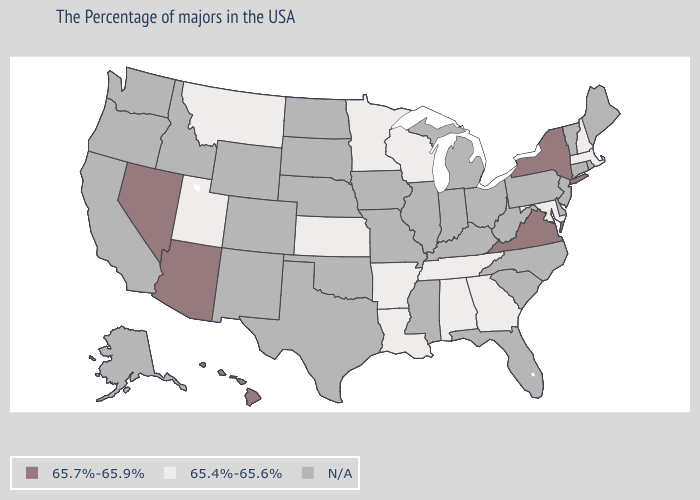Which states have the lowest value in the Northeast?
Quick response, please. Massachusetts, New Hampshire. What is the highest value in the Northeast ?
Keep it brief. 65.7%-65.9%. Which states have the lowest value in the West?
Be succinct. Utah, Montana. What is the value of Arizona?
Concise answer only. 65.7%-65.9%. Which states hav the highest value in the West?
Write a very short answer. Arizona, Nevada, Hawaii. What is the highest value in the South ?
Quick response, please. 65.7%-65.9%. Among the states that border Kentucky , which have the highest value?
Write a very short answer. Virginia. Does Virginia have the highest value in the USA?
Keep it brief. Yes. Name the states that have a value in the range 65.7%-65.9%?
Concise answer only. New York, Virginia, Arizona, Nevada, Hawaii. What is the value of Massachusetts?
Quick response, please. 65.4%-65.6%. Name the states that have a value in the range N/A?
Quick response, please. Maine, Rhode Island, Vermont, Connecticut, New Jersey, Delaware, Pennsylvania, North Carolina, South Carolina, West Virginia, Ohio, Florida, Michigan, Kentucky, Indiana, Illinois, Mississippi, Missouri, Iowa, Nebraska, Oklahoma, Texas, South Dakota, North Dakota, Wyoming, Colorado, New Mexico, Idaho, California, Washington, Oregon, Alaska. Does the map have missing data?
Quick response, please. Yes. Name the states that have a value in the range 65.7%-65.9%?
Answer briefly. New York, Virginia, Arizona, Nevada, Hawaii. Name the states that have a value in the range N/A?
Answer briefly. Maine, Rhode Island, Vermont, Connecticut, New Jersey, Delaware, Pennsylvania, North Carolina, South Carolina, West Virginia, Ohio, Florida, Michigan, Kentucky, Indiana, Illinois, Mississippi, Missouri, Iowa, Nebraska, Oklahoma, Texas, South Dakota, North Dakota, Wyoming, Colorado, New Mexico, Idaho, California, Washington, Oregon, Alaska. 